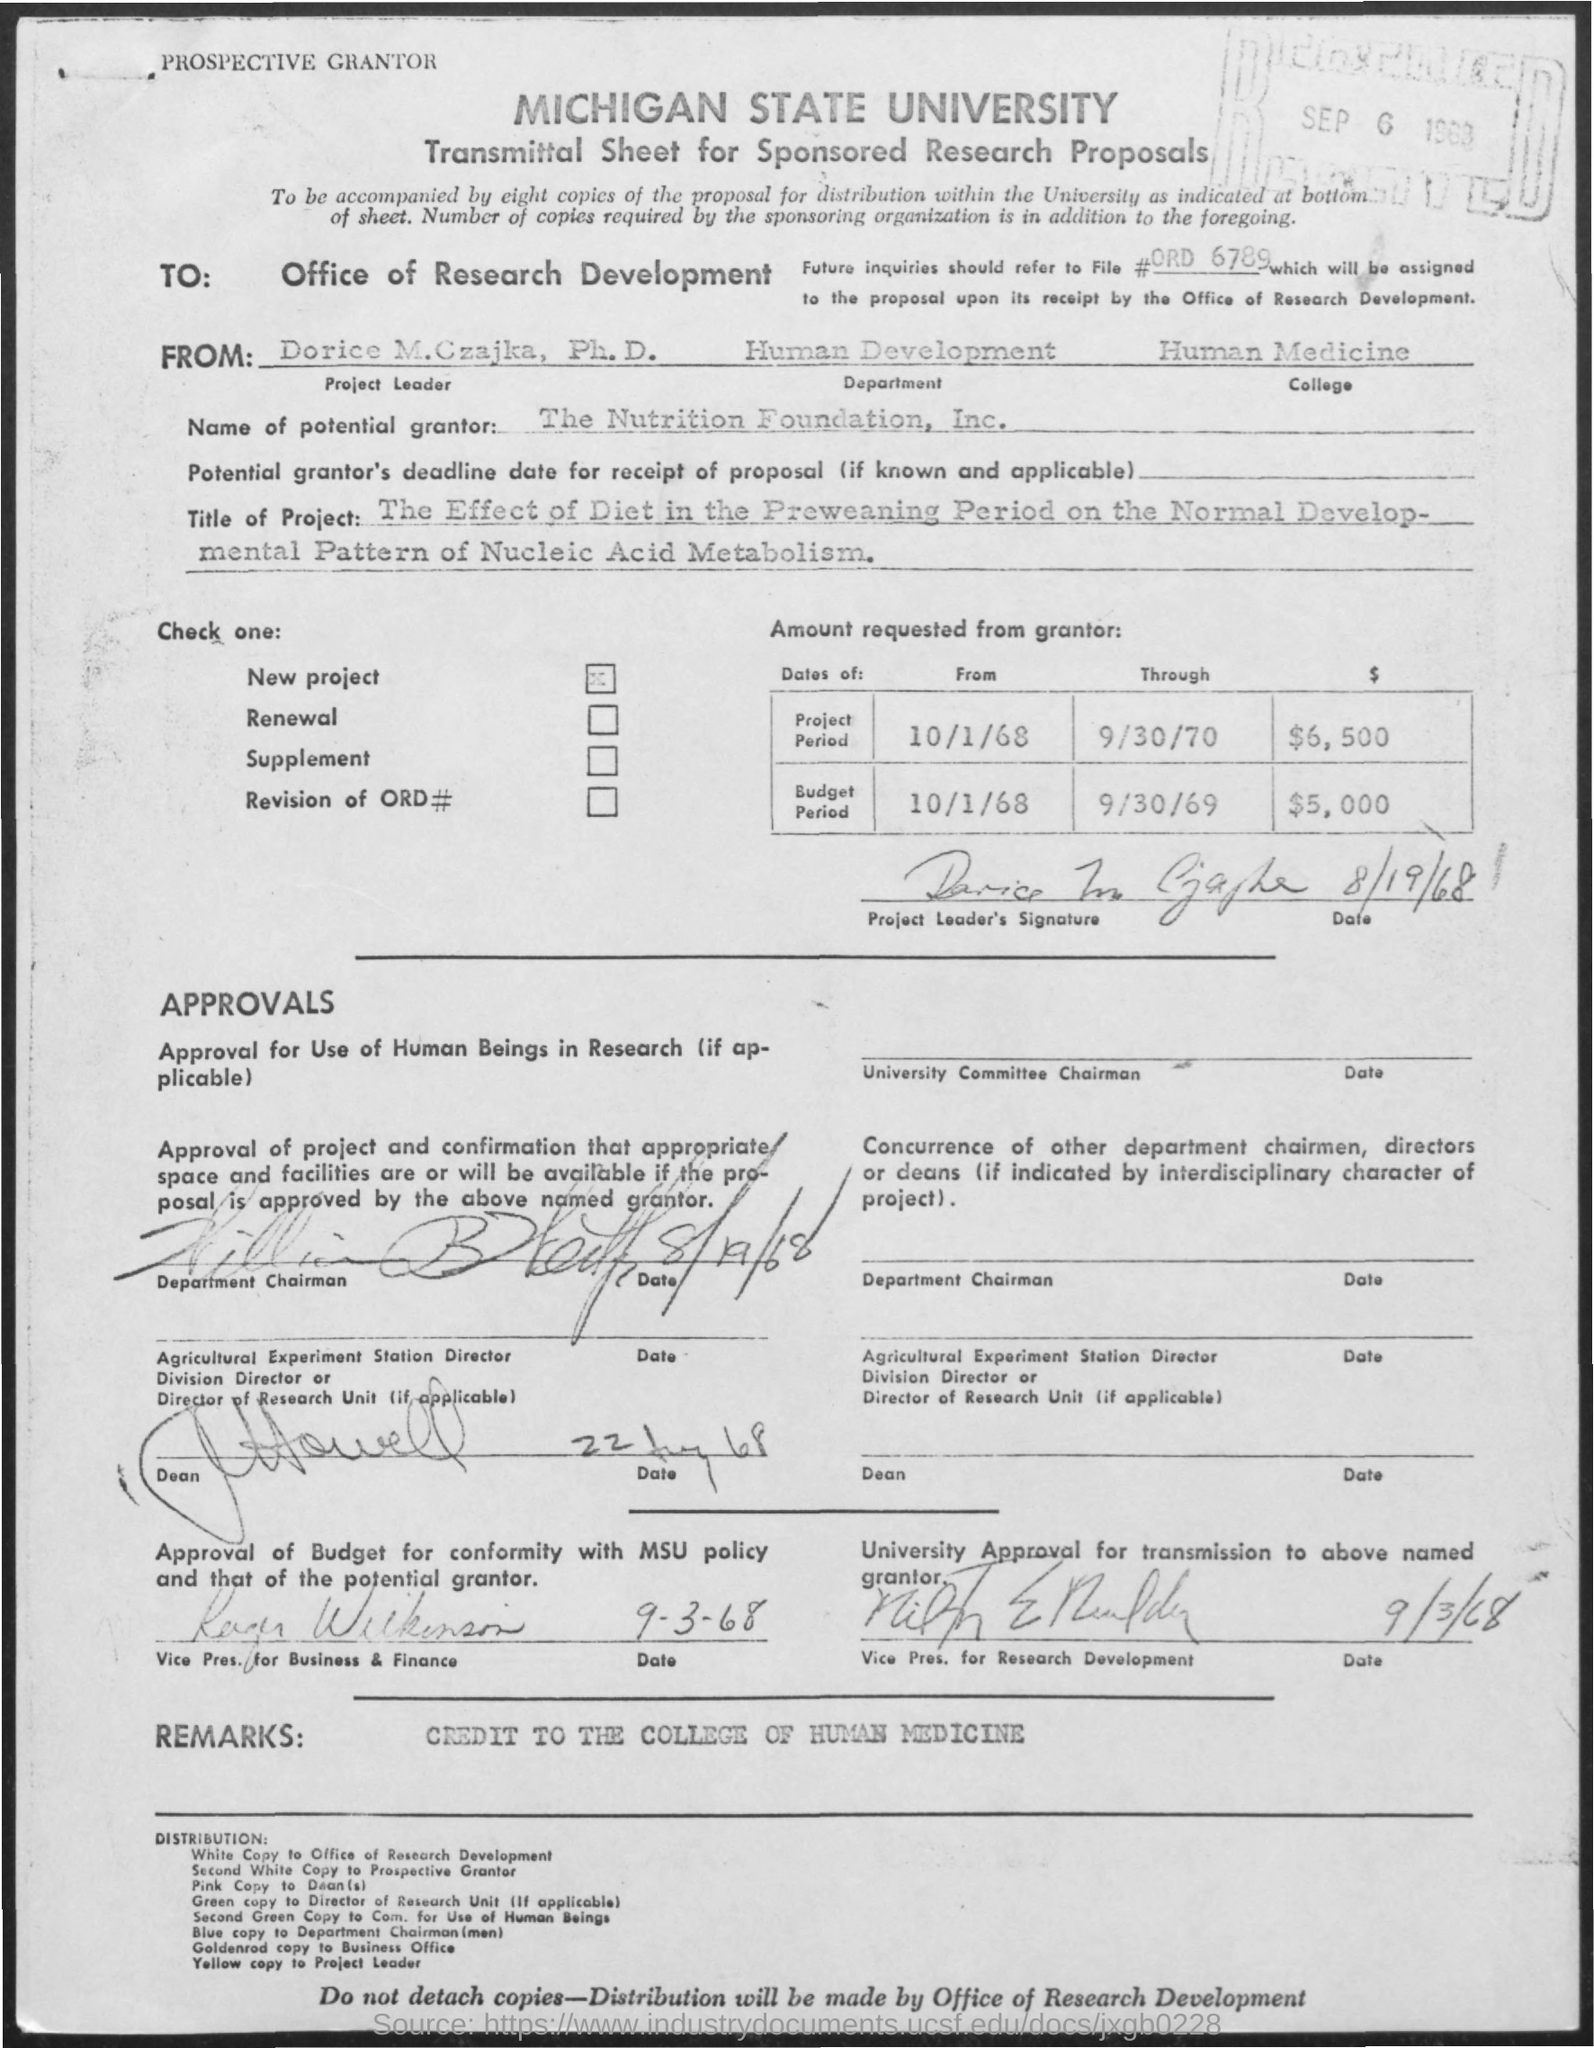What is the name of the university mentioned in the given form ?
Your answer should be very brief. Michigan state university. What is the received date mentioned ?
Your answer should be compact. SEP 6 1963. What is the name of the project leader mentioned ?
Your answer should be very brief. Dorice m. czajka. What is the department name mentioned ?
Your answer should be compact. HUMAN DEVELOPMENT. What is the college name mentioned ?
Provide a succinct answer. HUMAN MEDICINE. What is the title of the project mentioned in the given form ?
Provide a succinct answer. THE EFFECT OF DIET IN THE PREWEANING PERIOD ON THE NORMAL DEVELOPMENTAL PATTERN OF NUCLEIC ACID METABOLISM. What are the remarks mentioned ?
Make the answer very short. Credit to the college of human medicine. 